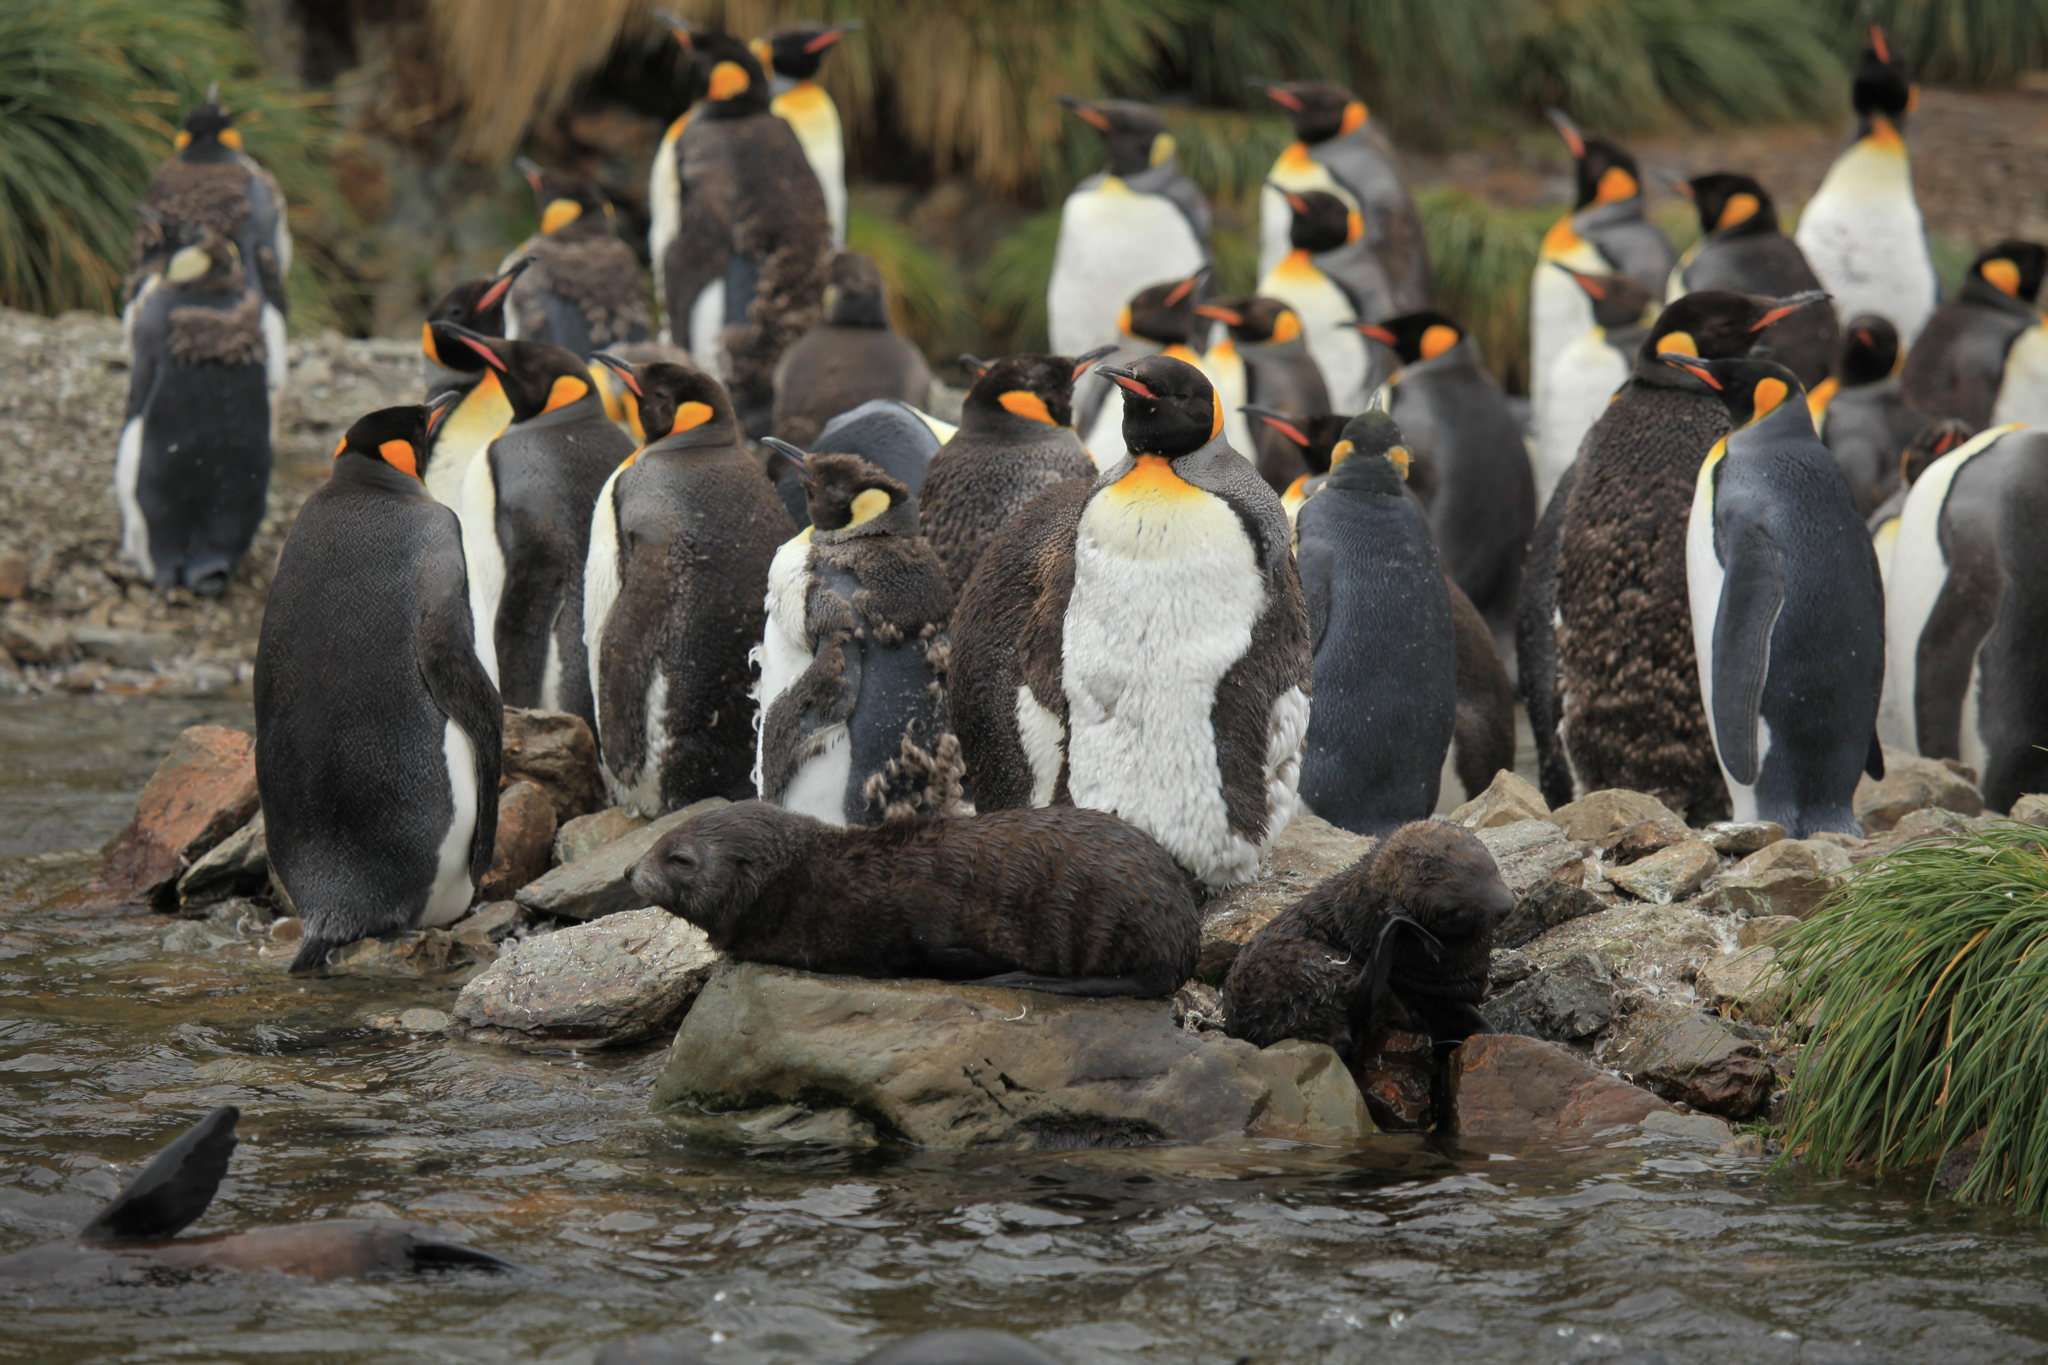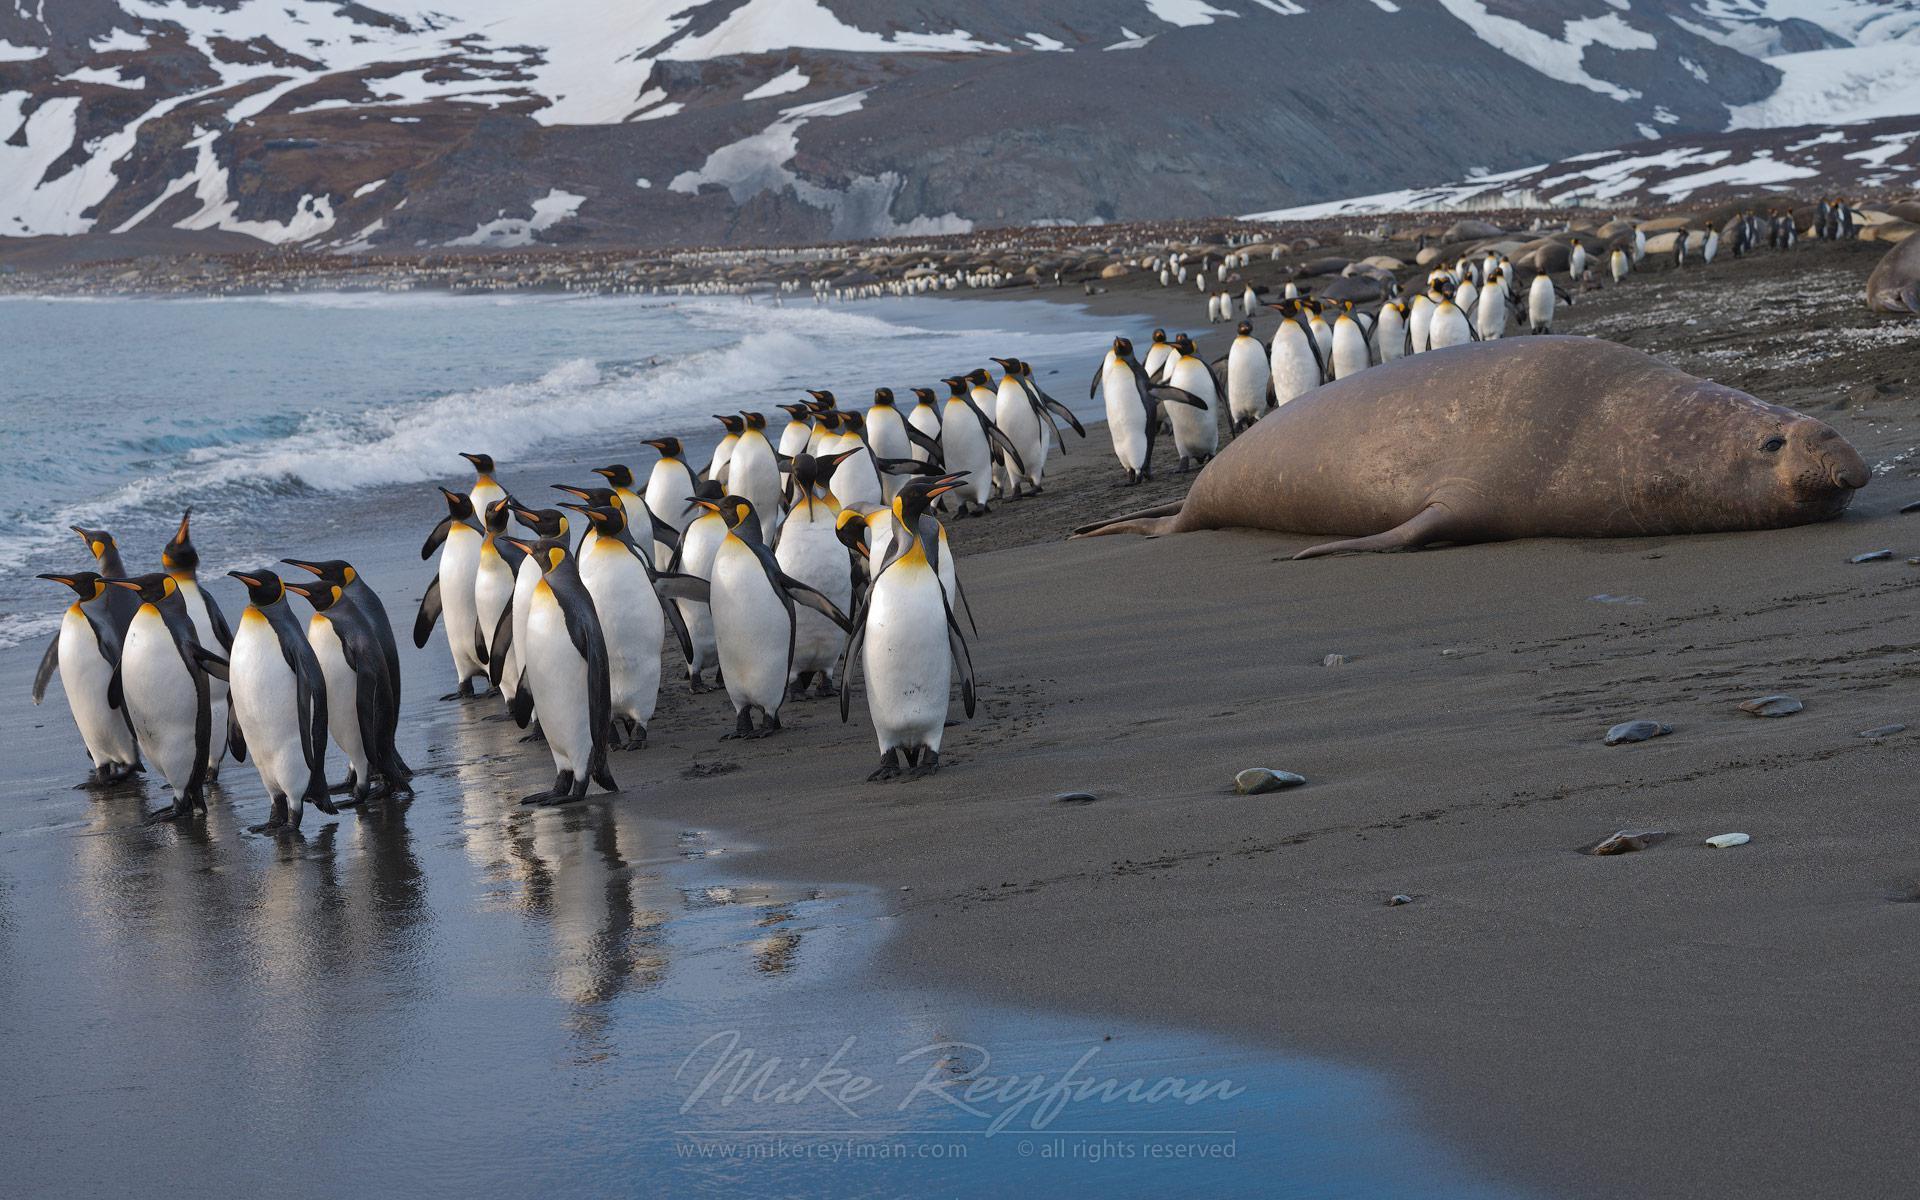The first image is the image on the left, the second image is the image on the right. Examine the images to the left and right. Is the description "In this image only land and sky are visible along side at least 8 penguins and a single sea lion." accurate? Answer yes or no. No. The first image is the image on the left, the second image is the image on the right. Analyze the images presented: Is the assertion "There is a group of penguins standing near the water's edge with no bird in the forefront." valid? Answer yes or no. Yes. 